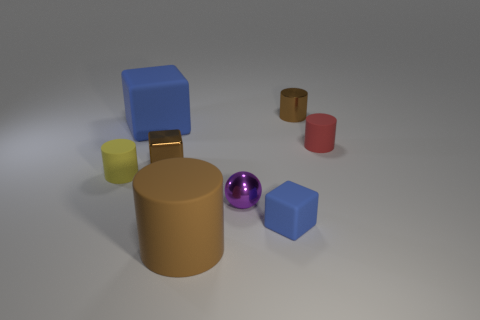Is the large cube the same color as the tiny shiny sphere?
Ensure brevity in your answer.  No. What number of green balls have the same material as the tiny purple object?
Offer a terse response. 0. How many objects are either metallic blocks that are right of the tiny yellow cylinder or small brown metallic objects on the left side of the brown metallic cylinder?
Provide a succinct answer. 1. Are there more small brown metal cylinders to the left of the yellow object than blue rubber things that are right of the small brown metallic cylinder?
Offer a terse response. No. There is a tiny matte thing that is left of the large cylinder; what is its color?
Provide a succinct answer. Yellow. Is there a brown matte object that has the same shape as the yellow rubber thing?
Give a very brief answer. Yes. What number of brown things are small shiny cylinders or metal cubes?
Keep it short and to the point. 2. Is there another cylinder that has the same size as the red cylinder?
Your answer should be compact. Yes. What number of gray rubber cylinders are there?
Ensure brevity in your answer.  0. How many large objects are balls or shiny cylinders?
Give a very brief answer. 0. 